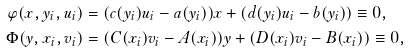Convert formula to latex. <formula><loc_0><loc_0><loc_500><loc_500>\varphi ( x , y _ { i } , u _ { i } ) & = ( c ( y _ { i } ) u _ { i } - a ( y _ { i } ) ) x + ( d ( y _ { i } ) u _ { i } - b ( y _ { i } ) ) \equiv 0 , \\ \Phi ( y , x _ { i } , v _ { i } ) & = ( C ( x _ { i } ) v _ { i } - A ( x _ { i } ) ) y + ( D ( x _ { i } ) v _ { i } - B ( x _ { i } ) ) \equiv 0 ,</formula> 